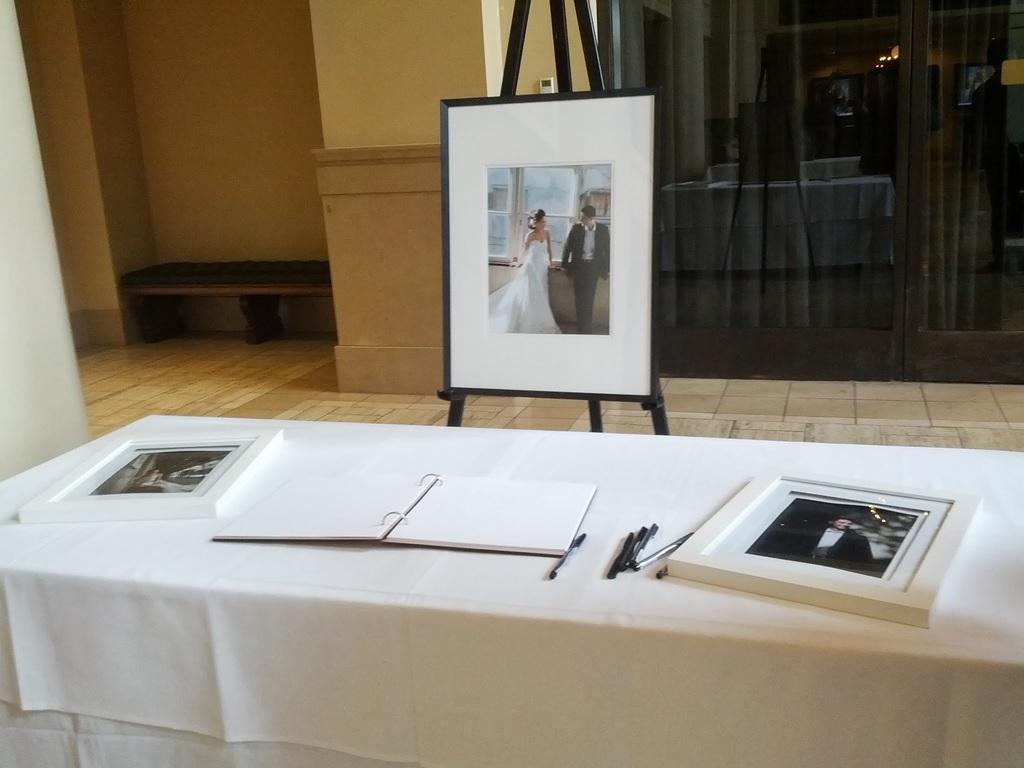What is the main subject of the photo frame in the image? The main subject of the photo frame in the image is a couple. How are the other frames positioned in relation to the couple's photo frame? The other frames are in front of the couple's photo frame. What can be found on the table in the image? There is a book and pens on the table in the image. What type of door is visible in the image? There is a glass door in the image. What is the background of the image made of? The background of the image includes a wall. What type of story is being told by the couple in the image? There is no story being told by the couple in the image; it is a photo of them. Can you tell me how many people are driving in the image? There is no driving activity or vehicles present in the image. 